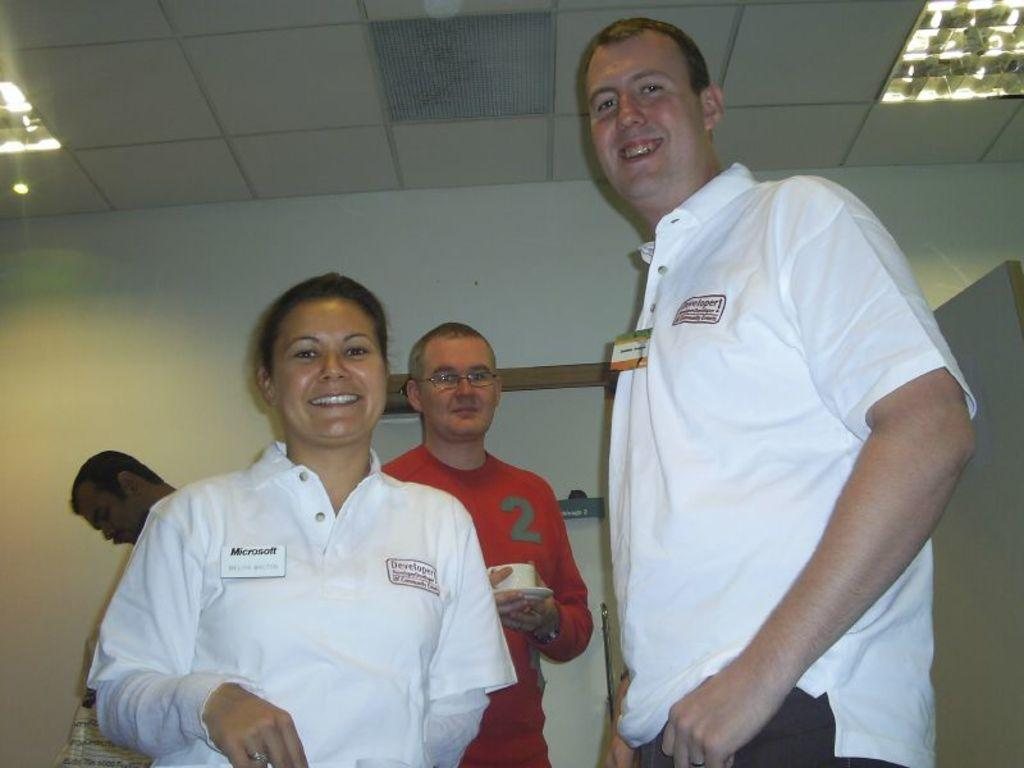How many people are in the image? There are three men and a woman in the image, making a total of four people. What are the people in the image doing? The people are standing in the image. What are the people wearing? The people are wearing clothes. What objects can be seen related to tea? There is a saucer and a tea cup in the image. What accessory can be seen in the image? There are spectacles in the image. What type of structure is visible in the image? There is a wall and a roof in the image, suggesting a building or room. What can be seen providing illumination in the image? There are lights in the image. What type of friction can be seen between the people in the image? There is no friction visible between the people in the image; they are simply standing. What emotion can be seen on the woman's face due to shame in the image? There is no indication of shame or any specific emotion on the woman's face in the image. 